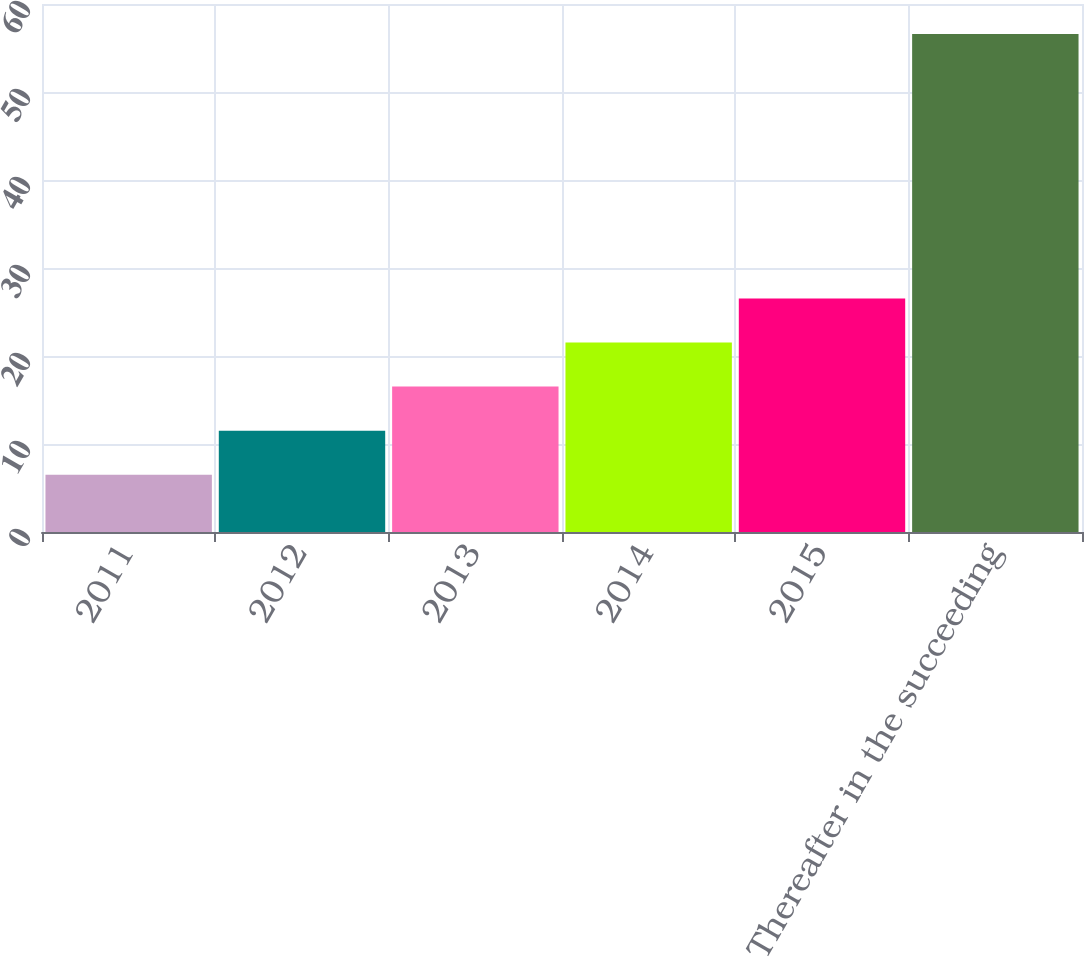Convert chart to OTSL. <chart><loc_0><loc_0><loc_500><loc_500><bar_chart><fcel>2011<fcel>2012<fcel>2013<fcel>2014<fcel>2015<fcel>Thereafter in the succeeding<nl><fcel>6.5<fcel>11.51<fcel>16.52<fcel>21.53<fcel>26.54<fcel>56.6<nl></chart> 